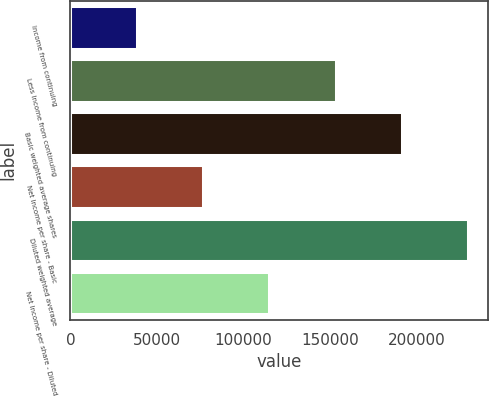Convert chart. <chart><loc_0><loc_0><loc_500><loc_500><bar_chart><fcel>Income from continuing<fcel>Less Income from continuing<fcel>Basic weighted average shares<fcel>Net Income per share - Basic<fcel>Diluted weighted average<fcel>Net Income per share - Diluted<nl><fcel>38274.3<fcel>153087<fcel>191357<fcel>76545.1<fcel>229628<fcel>114816<nl></chart> 